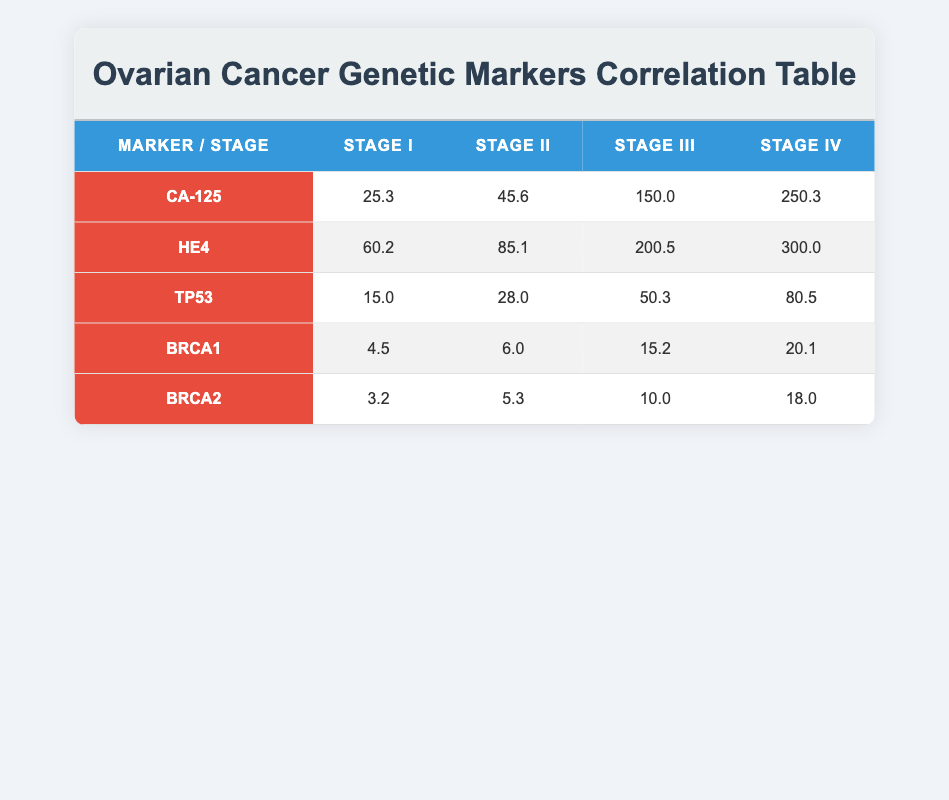What is the expression level of CA-125 at Stage III? The expression level of CA-125 at Stage III is found directly in the table under the corresponding column for Stage III. It shows a value of 150.0.
Answer: 150.0 What is the expression level of HE4 at Stage I? The expression level of HE4 at Stage I is listed in the table under the Stage I column associated with HE4. The value is 60.2.
Answer: 60.2 Which marker has the highest expression level at Stage IV? To find the highest expression level at Stage IV, we compare the values for CA-125 (250.3), HE4 (300.0), TP53 (80.5), BRCA1 (20.1), and BRCA2 (18.0). HE4 has the highest value of 300.0.
Answer: HE4 What is the average expression level of BRCA1 across all stages? The values of BRCA1 are 4.5, 6.0, 15.2, and 20.1 across the stages. The sum is 4.5 + 6.0 + 15.2 + 20.1 = 45.8. Since there are 4 stages, the average is 45.8 / 4 = 11.45.
Answer: 11.45 Is the expression level of TP53 in Stage II greater than that in Stage I? The expression level of TP53 in Stage II is 28.0, and in Stage I it is 15.0. Since 28.0 is greater than 15.0, the statement is true.
Answer: Yes What is the difference in expression levels of CA-125 between Stage IV and Stage I? The expression level of CA-125 in Stage IV is 250.3 and in Stage I is 25.3. The difference is calculated as 250.3 - 25.3 = 225.0.
Answer: 225.0 Which stage shows the lowest expression level for BRCA2? To determine the stage with the lowest expression level for BRCA2, we check the values: Stage I has 3.2, Stage II has 5.3, Stage III has 10.0, and Stage IV has 18.0. The lowest value is 3.2 at Stage I.
Answer: Stage I What is the total expression level of HE4 and TP53 at Stage III? At Stage III, the expression level of HE4 is 200.5 and TP53 is 50.3. The total is calculated as 200.5 + 50.3 = 250.8.
Answer: 250.8 Is there any stage where the expression level of BRCA2 exceeds 15? The expression levels for BRCA2 are 3.2, 5.3, 10.0, and 18.0 in Stages I, II, III, and IV respectively. Therefore, there is no stage where BRCA2 exceeds 15 based on the highest value.
Answer: No 